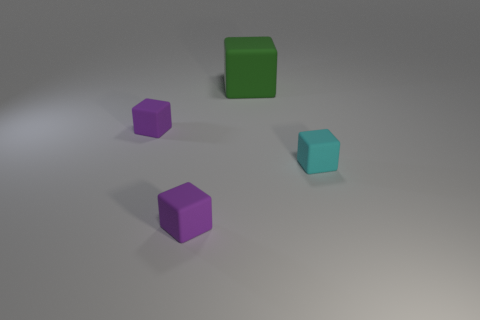What shape is the large thing?
Your answer should be compact. Cube. There is a object that is in front of the small cyan matte object in front of the green cube; what is its size?
Give a very brief answer. Small. Are there an equal number of tiny matte blocks that are behind the large green matte thing and purple blocks that are behind the cyan matte thing?
Ensure brevity in your answer.  No. There is a cyan object; is it the same size as the thing that is in front of the cyan block?
Your answer should be very brief. Yes. Are there more small blocks that are to the left of the big rubber block than big gray things?
Keep it short and to the point. Yes. The tiny rubber thing to the right of the small purple rubber thing in front of the object that is right of the big green thing is what color?
Offer a terse response. Cyan. Are there any gray rubber spheres that have the same size as the cyan thing?
Offer a terse response. No. Is there another object of the same shape as the small cyan object?
Make the answer very short. Yes. What shape is the cyan rubber thing in front of the big block?
Offer a terse response. Cube. How many tiny purple matte objects are there?
Make the answer very short. 2. 